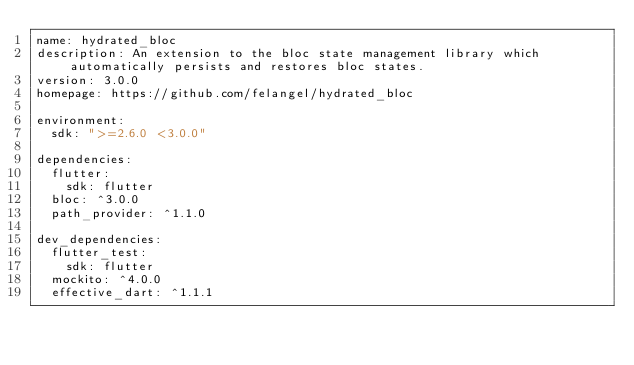<code> <loc_0><loc_0><loc_500><loc_500><_YAML_>name: hydrated_bloc
description: An extension to the bloc state management library which automatically persists and restores bloc states.
version: 3.0.0
homepage: https://github.com/felangel/hydrated_bloc

environment:
  sdk: ">=2.6.0 <3.0.0"

dependencies:
  flutter:
    sdk: flutter
  bloc: ^3.0.0
  path_provider: ^1.1.0

dev_dependencies:
  flutter_test:
    sdk: flutter
  mockito: ^4.0.0
  effective_dart: ^1.1.1
</code> 